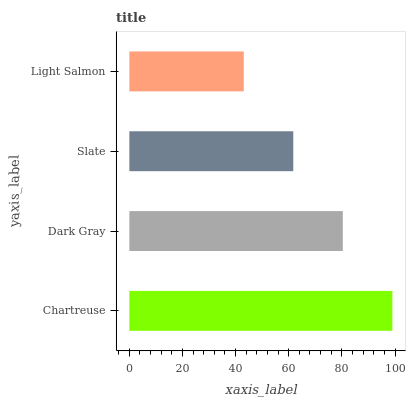Is Light Salmon the minimum?
Answer yes or no. Yes. Is Chartreuse the maximum?
Answer yes or no. Yes. Is Dark Gray the minimum?
Answer yes or no. No. Is Dark Gray the maximum?
Answer yes or no. No. Is Chartreuse greater than Dark Gray?
Answer yes or no. Yes. Is Dark Gray less than Chartreuse?
Answer yes or no. Yes. Is Dark Gray greater than Chartreuse?
Answer yes or no. No. Is Chartreuse less than Dark Gray?
Answer yes or no. No. Is Dark Gray the high median?
Answer yes or no. Yes. Is Slate the low median?
Answer yes or no. Yes. Is Chartreuse the high median?
Answer yes or no. No. Is Chartreuse the low median?
Answer yes or no. No. 